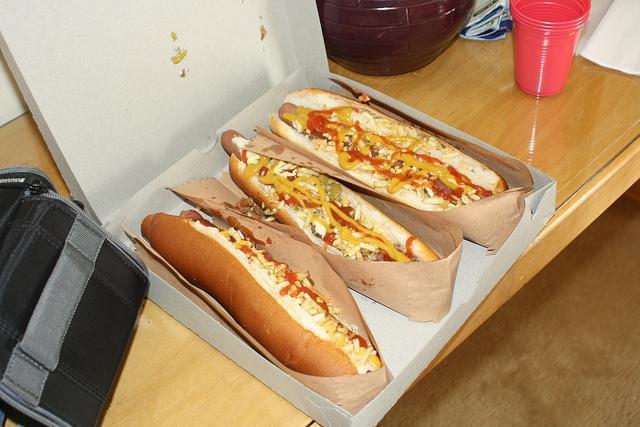How many hot dogs are in the photo?
Give a very brief answer. 3. 